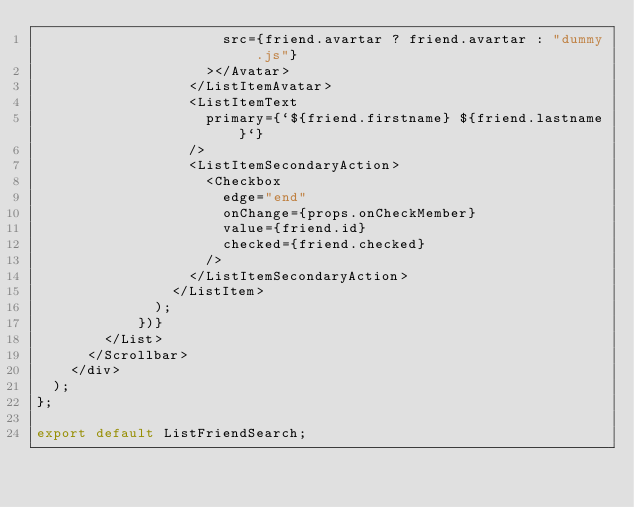Convert code to text. <code><loc_0><loc_0><loc_500><loc_500><_JavaScript_>                      src={friend.avartar ? friend.avartar : "dummy.js"}
                    ></Avatar>
                  </ListItemAvatar>
                  <ListItemText
                    primary={`${friend.firstname} ${friend.lastname}`}
                  />
                  <ListItemSecondaryAction>
                    <Checkbox
                      edge="end"
                      onChange={props.onCheckMember}
                      value={friend.id}
                      checked={friend.checked}
                    />
                  </ListItemSecondaryAction>
                </ListItem>
              );
            })}
        </List>
      </Scrollbar>
    </div>
  );
};

export default ListFriendSearch;
</code> 